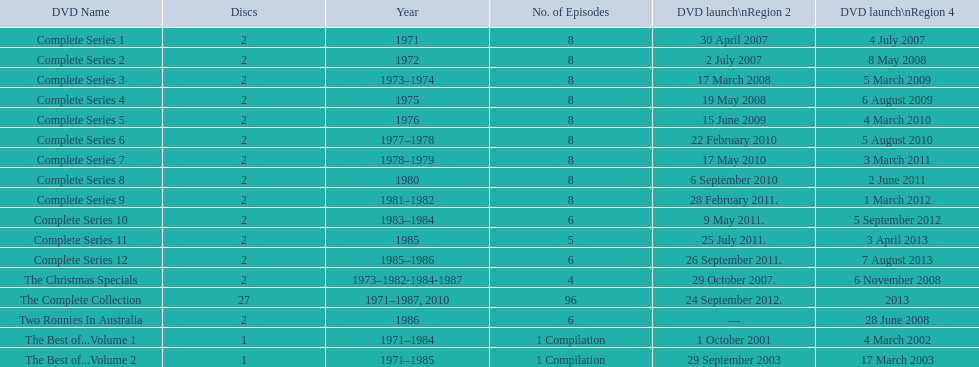The television show "the two ronnies" ran for a total of how many seasons? 12. 